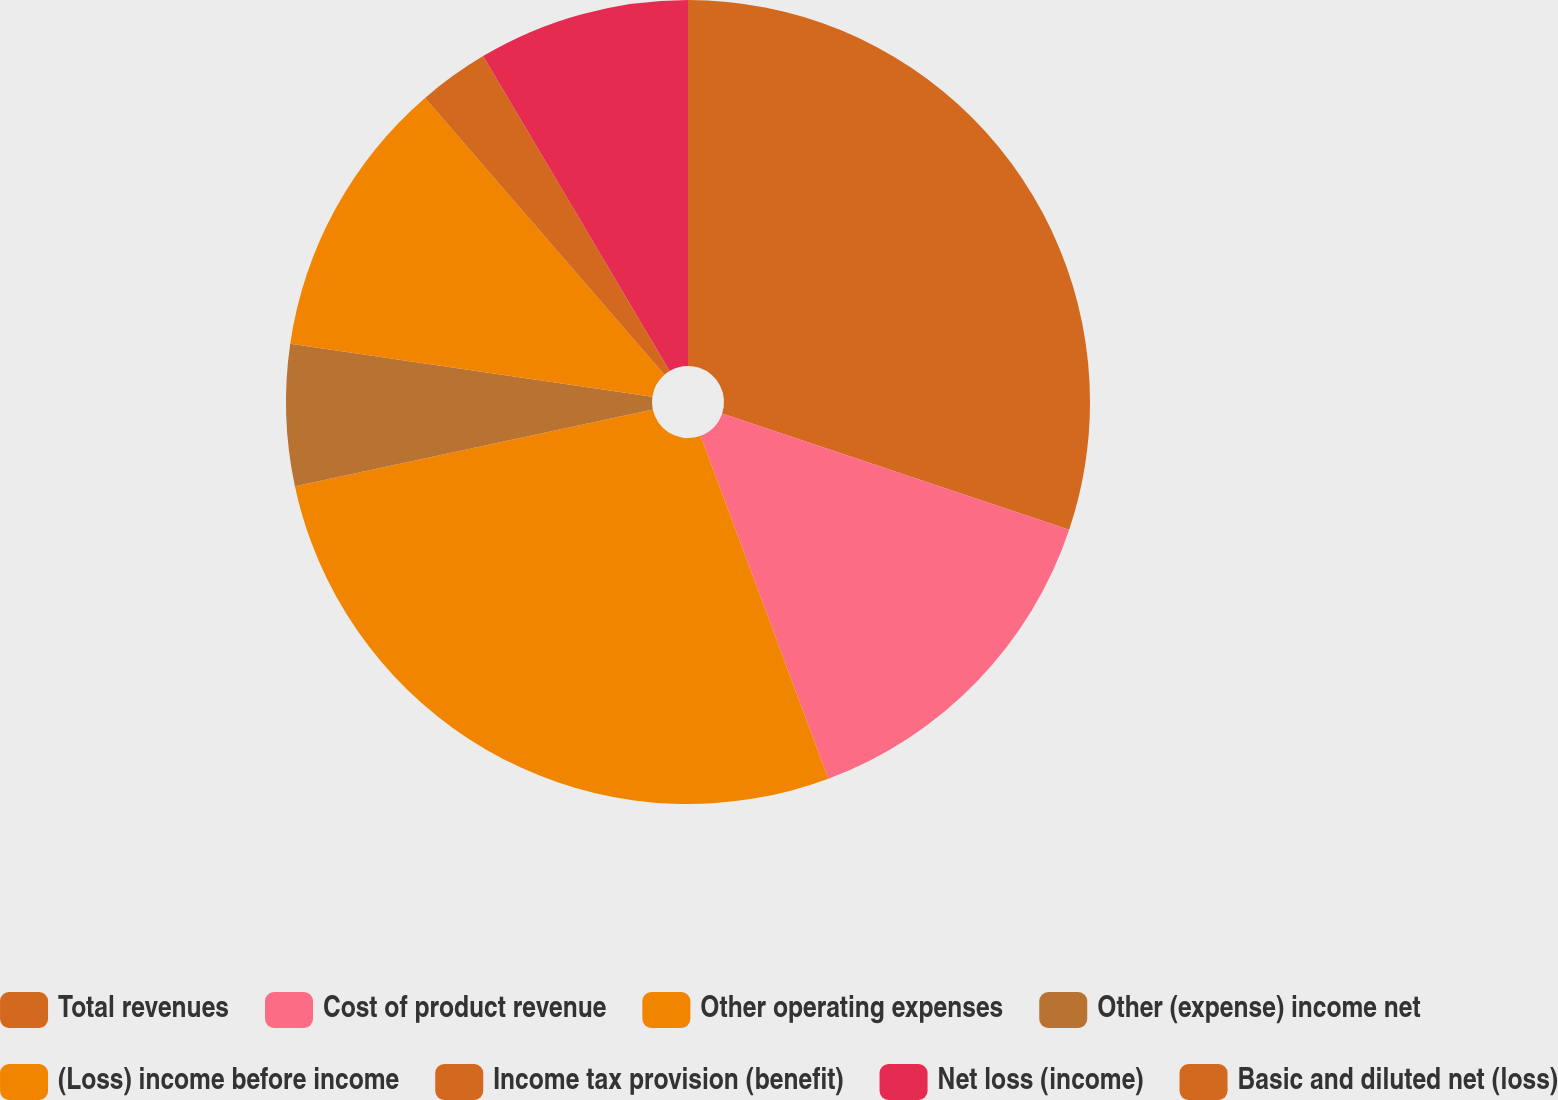<chart> <loc_0><loc_0><loc_500><loc_500><pie_chart><fcel>Total revenues<fcel>Cost of product revenue<fcel>Other operating expenses<fcel>Other (expense) income net<fcel>(Loss) income before income<fcel>Income tax provision (benefit)<fcel>Net loss (income)<fcel>Basic and diluted net (loss)<nl><fcel>30.15%<fcel>14.18%<fcel>27.32%<fcel>5.67%<fcel>11.34%<fcel>2.84%<fcel>8.51%<fcel>0.0%<nl></chart> 